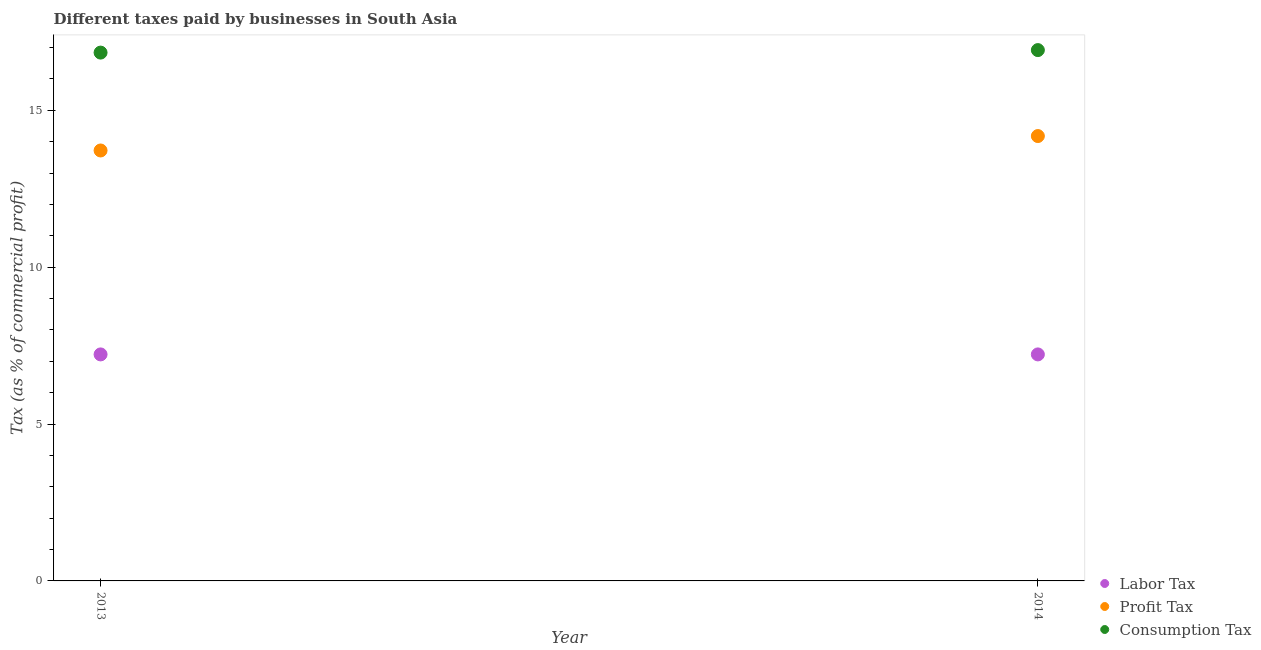How many different coloured dotlines are there?
Ensure brevity in your answer.  3. Is the number of dotlines equal to the number of legend labels?
Provide a succinct answer. Yes. What is the percentage of profit tax in 2013?
Keep it short and to the point. 13.72. Across all years, what is the maximum percentage of consumption tax?
Make the answer very short. 16.92. Across all years, what is the minimum percentage of consumption tax?
Keep it short and to the point. 16.84. In which year was the percentage of profit tax minimum?
Your answer should be very brief. 2013. What is the total percentage of profit tax in the graph?
Ensure brevity in your answer.  27.9. What is the difference between the percentage of consumption tax in 2013 and that in 2014?
Give a very brief answer. -0.08. What is the difference between the percentage of labor tax in 2014 and the percentage of consumption tax in 2013?
Provide a succinct answer. -9.62. What is the average percentage of profit tax per year?
Make the answer very short. 13.95. In the year 2014, what is the difference between the percentage of labor tax and percentage of profit tax?
Your answer should be very brief. -6.96. In how many years, is the percentage of consumption tax greater than 13 %?
Ensure brevity in your answer.  2. Is it the case that in every year, the sum of the percentage of labor tax and percentage of profit tax is greater than the percentage of consumption tax?
Your answer should be compact. Yes. Is the percentage of profit tax strictly greater than the percentage of consumption tax over the years?
Offer a very short reply. No. How many dotlines are there?
Ensure brevity in your answer.  3. How many years are there in the graph?
Ensure brevity in your answer.  2. Are the values on the major ticks of Y-axis written in scientific E-notation?
Ensure brevity in your answer.  No. Does the graph contain any zero values?
Give a very brief answer. No. Does the graph contain grids?
Your answer should be very brief. No. How are the legend labels stacked?
Offer a very short reply. Vertical. What is the title of the graph?
Offer a terse response. Different taxes paid by businesses in South Asia. Does "Nuclear sources" appear as one of the legend labels in the graph?
Give a very brief answer. No. What is the label or title of the X-axis?
Keep it short and to the point. Year. What is the label or title of the Y-axis?
Your response must be concise. Tax (as % of commercial profit). What is the Tax (as % of commercial profit) in Labor Tax in 2013?
Ensure brevity in your answer.  7.22. What is the Tax (as % of commercial profit) in Profit Tax in 2013?
Give a very brief answer. 13.72. What is the Tax (as % of commercial profit) in Consumption Tax in 2013?
Provide a short and direct response. 16.84. What is the Tax (as % of commercial profit) in Labor Tax in 2014?
Your answer should be compact. 7.22. What is the Tax (as % of commercial profit) of Profit Tax in 2014?
Ensure brevity in your answer.  14.18. What is the Tax (as % of commercial profit) in Consumption Tax in 2014?
Give a very brief answer. 16.92. Across all years, what is the maximum Tax (as % of commercial profit) of Labor Tax?
Provide a short and direct response. 7.22. Across all years, what is the maximum Tax (as % of commercial profit) in Profit Tax?
Offer a terse response. 14.18. Across all years, what is the maximum Tax (as % of commercial profit) in Consumption Tax?
Offer a terse response. 16.92. Across all years, what is the minimum Tax (as % of commercial profit) of Labor Tax?
Your answer should be very brief. 7.22. Across all years, what is the minimum Tax (as % of commercial profit) in Profit Tax?
Offer a very short reply. 13.72. Across all years, what is the minimum Tax (as % of commercial profit) of Consumption Tax?
Your response must be concise. 16.84. What is the total Tax (as % of commercial profit) of Labor Tax in the graph?
Provide a short and direct response. 14.44. What is the total Tax (as % of commercial profit) of Profit Tax in the graph?
Ensure brevity in your answer.  27.9. What is the total Tax (as % of commercial profit) in Consumption Tax in the graph?
Your answer should be compact. 33.76. What is the difference between the Tax (as % of commercial profit) of Labor Tax in 2013 and that in 2014?
Ensure brevity in your answer.  0. What is the difference between the Tax (as % of commercial profit) in Profit Tax in 2013 and that in 2014?
Give a very brief answer. -0.46. What is the difference between the Tax (as % of commercial profit) in Consumption Tax in 2013 and that in 2014?
Ensure brevity in your answer.  -0.08. What is the difference between the Tax (as % of commercial profit) of Labor Tax in 2013 and the Tax (as % of commercial profit) of Profit Tax in 2014?
Make the answer very short. -6.96. What is the difference between the Tax (as % of commercial profit) in Labor Tax in 2013 and the Tax (as % of commercial profit) in Consumption Tax in 2014?
Make the answer very short. -9.7. What is the average Tax (as % of commercial profit) of Labor Tax per year?
Provide a succinct answer. 7.22. What is the average Tax (as % of commercial profit) in Profit Tax per year?
Offer a very short reply. 13.95. What is the average Tax (as % of commercial profit) in Consumption Tax per year?
Your answer should be very brief. 16.88. In the year 2013, what is the difference between the Tax (as % of commercial profit) in Labor Tax and Tax (as % of commercial profit) in Consumption Tax?
Provide a succinct answer. -9.62. In the year 2013, what is the difference between the Tax (as % of commercial profit) of Profit Tax and Tax (as % of commercial profit) of Consumption Tax?
Your answer should be compact. -3.12. In the year 2014, what is the difference between the Tax (as % of commercial profit) in Labor Tax and Tax (as % of commercial profit) in Profit Tax?
Keep it short and to the point. -6.96. In the year 2014, what is the difference between the Tax (as % of commercial profit) in Profit Tax and Tax (as % of commercial profit) in Consumption Tax?
Give a very brief answer. -2.74. What is the ratio of the Tax (as % of commercial profit) of Labor Tax in 2013 to that in 2014?
Give a very brief answer. 1. What is the ratio of the Tax (as % of commercial profit) of Profit Tax in 2013 to that in 2014?
Your answer should be compact. 0.97. What is the ratio of the Tax (as % of commercial profit) in Consumption Tax in 2013 to that in 2014?
Keep it short and to the point. 1. What is the difference between the highest and the second highest Tax (as % of commercial profit) in Profit Tax?
Make the answer very short. 0.46. What is the difference between the highest and the lowest Tax (as % of commercial profit) in Profit Tax?
Provide a short and direct response. 0.46. 